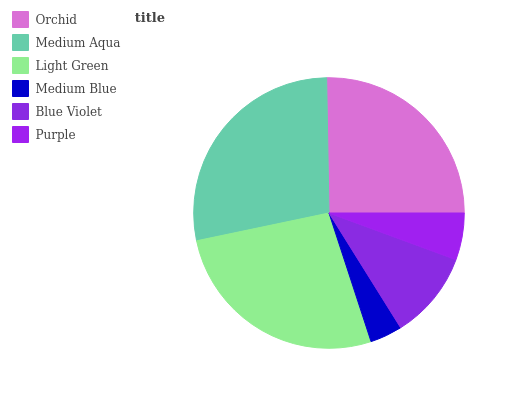Is Medium Blue the minimum?
Answer yes or no. Yes. Is Medium Aqua the maximum?
Answer yes or no. Yes. Is Light Green the minimum?
Answer yes or no. No. Is Light Green the maximum?
Answer yes or no. No. Is Medium Aqua greater than Light Green?
Answer yes or no. Yes. Is Light Green less than Medium Aqua?
Answer yes or no. Yes. Is Light Green greater than Medium Aqua?
Answer yes or no. No. Is Medium Aqua less than Light Green?
Answer yes or no. No. Is Orchid the high median?
Answer yes or no. Yes. Is Blue Violet the low median?
Answer yes or no. Yes. Is Purple the high median?
Answer yes or no. No. Is Medium Aqua the low median?
Answer yes or no. No. 